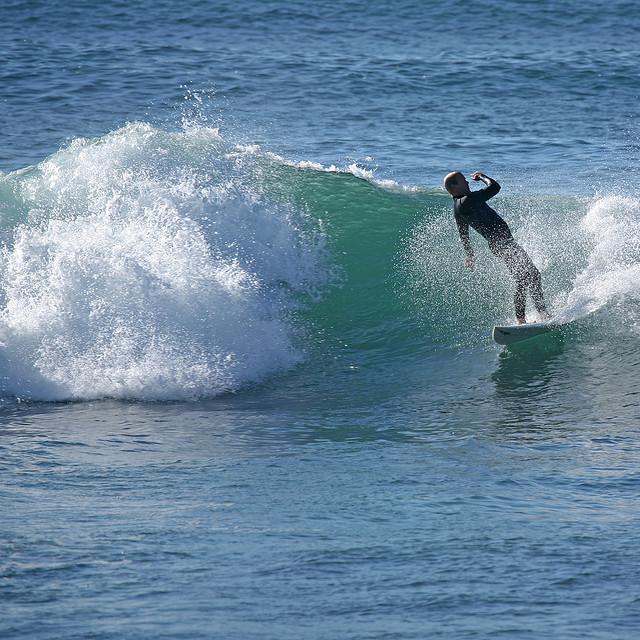How many boys are there in the sea?
Give a very brief answer. 1. How many people are surfing?
Give a very brief answer. 1. How many surfers are in this photo?
Give a very brief answer. 1. How many people are in the water?
Give a very brief answer. 1. 